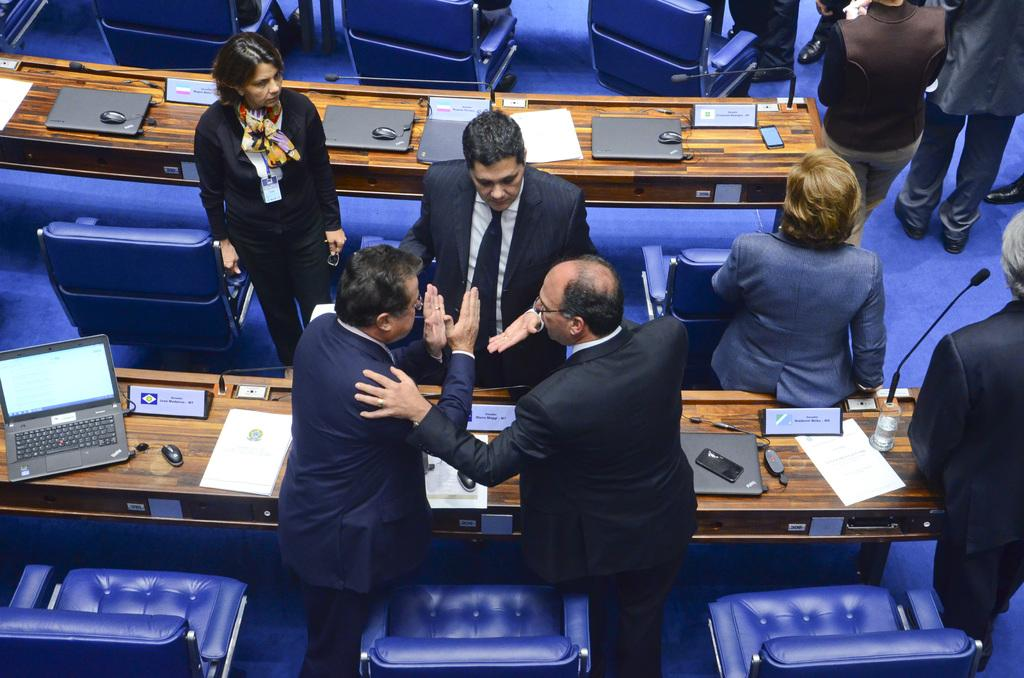How many people are the people are in the image? There is a group of people in the image. What are the people doing in the image? The people are standing in front of a table. What objects can be seen on the table? There is a laptop, a mobile, a glass, and a board on the table. How many babies are crawling on the table in the image? There are no babies present in the image, and they are not crawling on the table. What type of mailbox is visible in the image? There is no mailbox present in the image. 